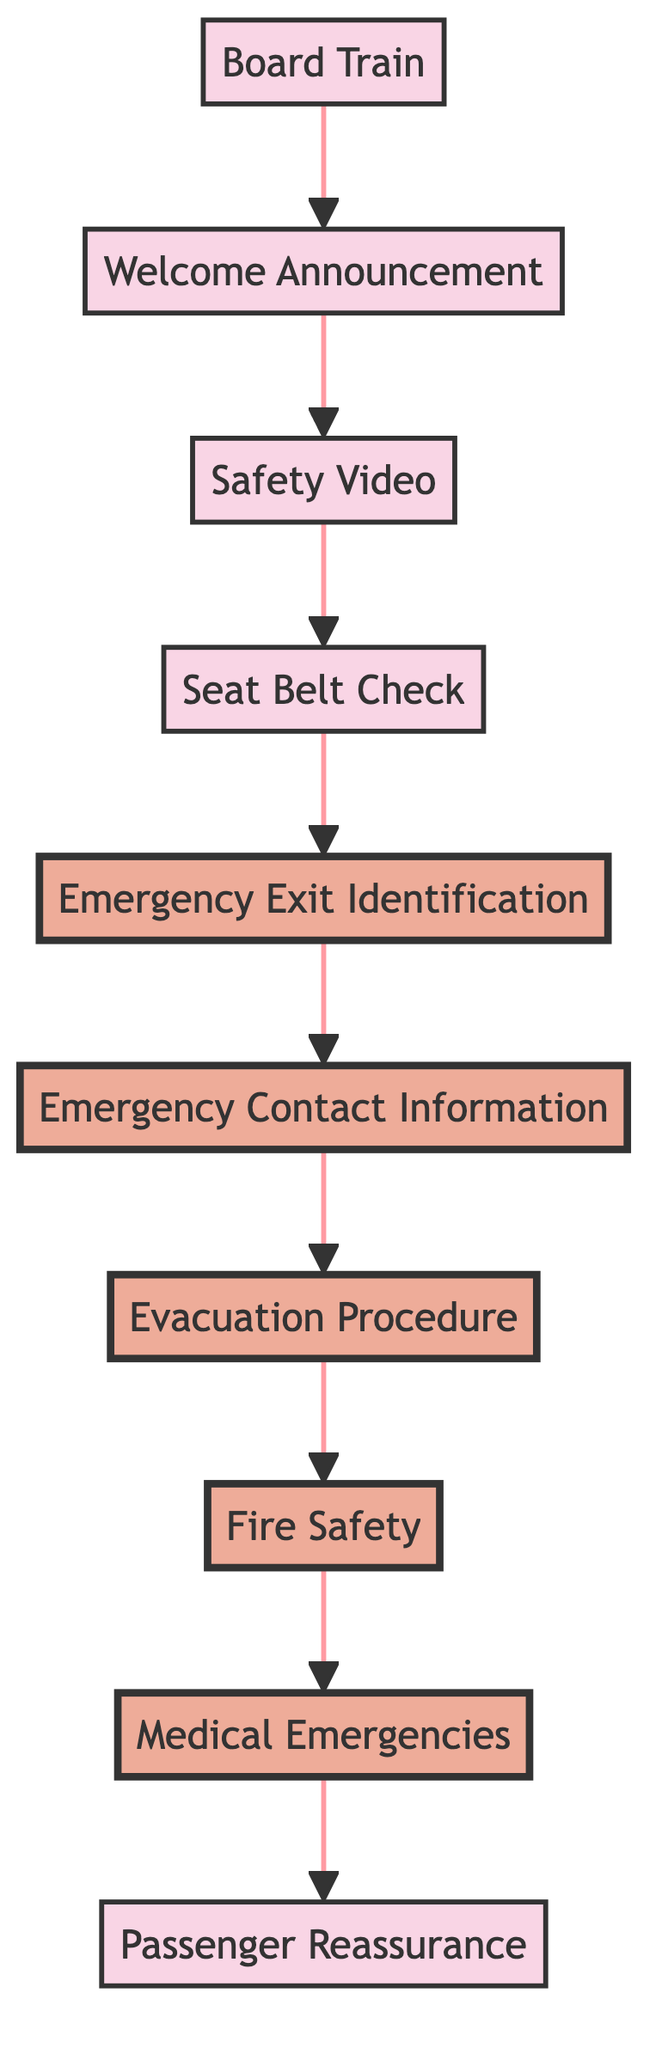What is the first step in the flowchart? The first step in the flowchart is "Board Train," which indicates that passengers begin by boarding the train and finding their seats.
Answer: Board Train How many nodes are there in total? By counting each item in the flowchart, there are ten distinct nodes, including "Board Train" through "Passenger Reassurance."
Answer: 10 What is the last step of the flowchart? The last step in the flowchart is "Passenger Reassurance," which follows all the safety procedures and provides continued support to passengers.
Answer: Passenger Reassurance Which step directly follows the "Welcome Announcement"? "Safety Video" directly follows the "Welcome Announcement," indicating that after greeting the passengers, the next action is to show a safety video.
Answer: Safety Video What is the step before "Evacuation Procedure"? The step before "Evacuation Procedure" is "Emergency Contact Information," showing that passengers are informed about how to contact staff prior to learning evacuation details.
Answer: Emergency Contact Information How many highlighted steps are in the diagram? There are six highlighted steps in the diagram, which emphasize the critical parts of safety and emergency procedures.
Answer: 6 What is the step that discusses fire safety? The step that discusses fire safety is labeled "Fire Safety," where guidelines on how to manage a fire situation are provided to passengers.
Answer: Fire Safety Which two steps are connected directly to "Emergency Exit Identification"? "Seat Belt Check" is connected directly to "Emergency Exit Identification" as its predecessor, and "Emergency Contact Information" is its successor.
Answer: Seat Belt Check and Emergency Contact Information What is the primary focus of the "Medical Emergencies" step? The primary focus of "Medical Emergencies" is to provide instructions on handling medical situations, including notifying the conductor and using the first aid kit.
Answer: Medical Emergencies 